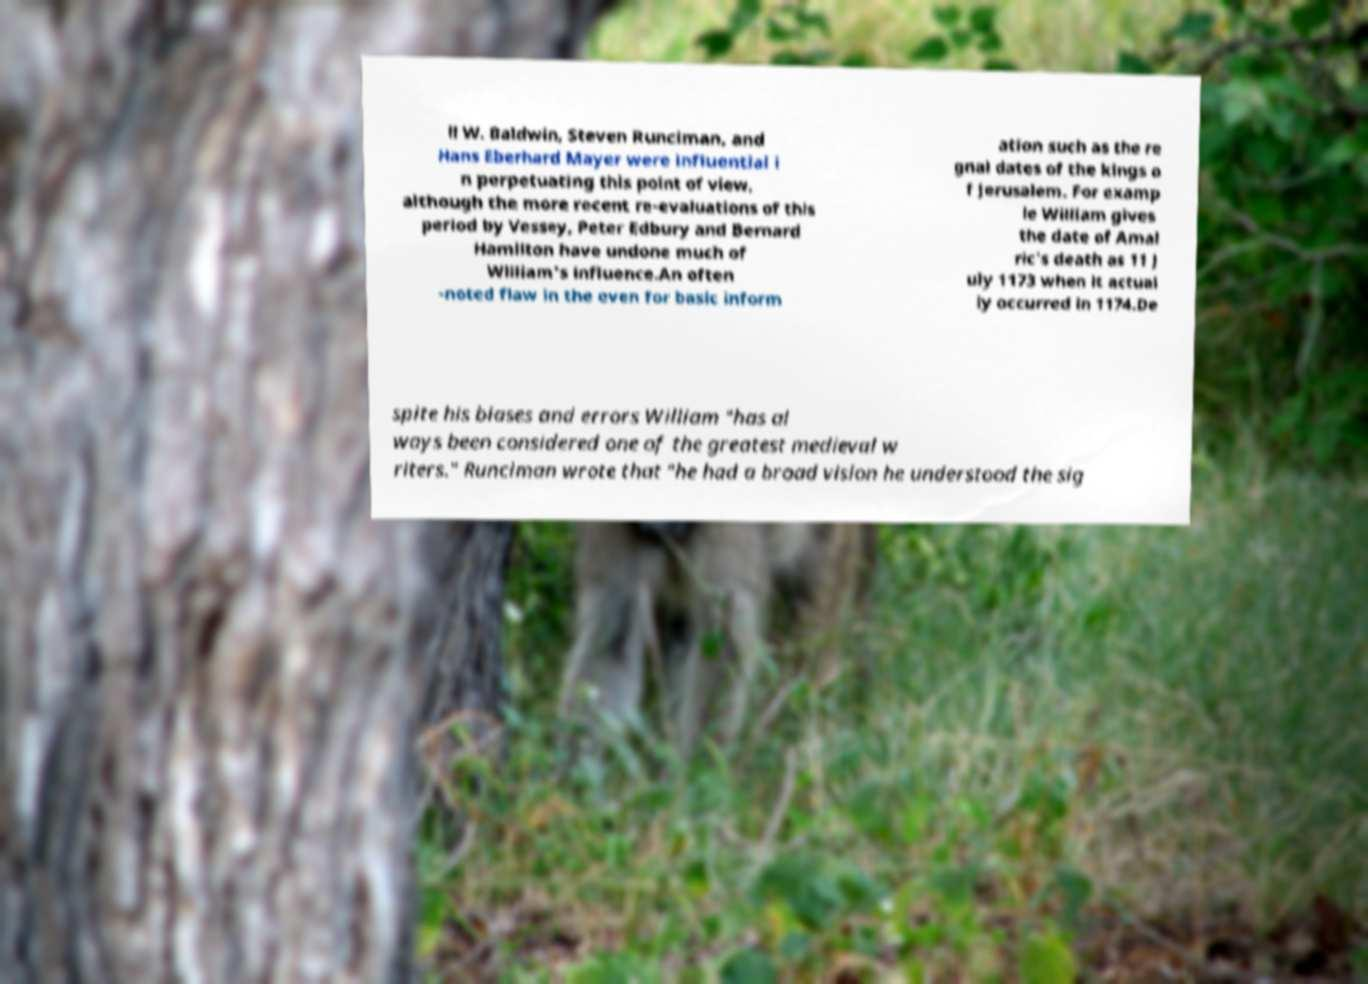Can you read and provide the text displayed in the image?This photo seems to have some interesting text. Can you extract and type it out for me? ll W. Baldwin, Steven Runciman, and Hans Eberhard Mayer were influential i n perpetuating this point of view, although the more recent re-evaluations of this period by Vessey, Peter Edbury and Bernard Hamilton have undone much of William's influence.An often -noted flaw in the even for basic inform ation such as the re gnal dates of the kings o f Jerusalem. For examp le William gives the date of Amal ric's death as 11 J uly 1173 when it actual ly occurred in 1174.De spite his biases and errors William "has al ways been considered one of the greatest medieval w riters." Runciman wrote that "he had a broad vision he understood the sig 